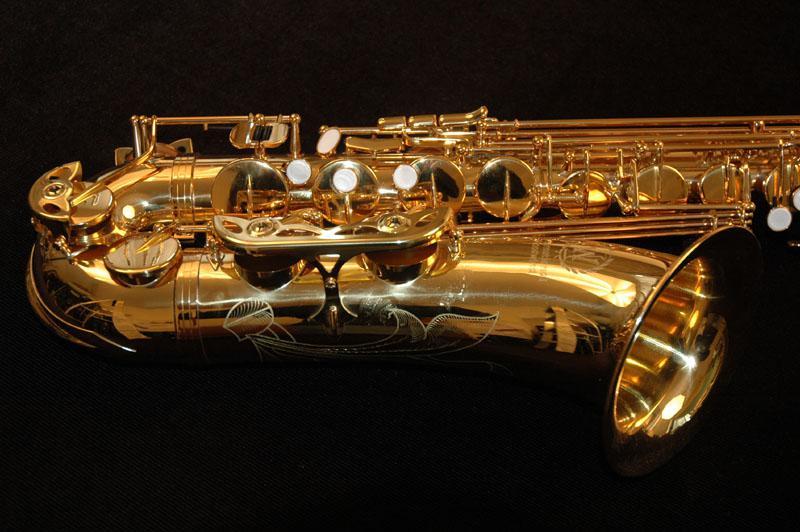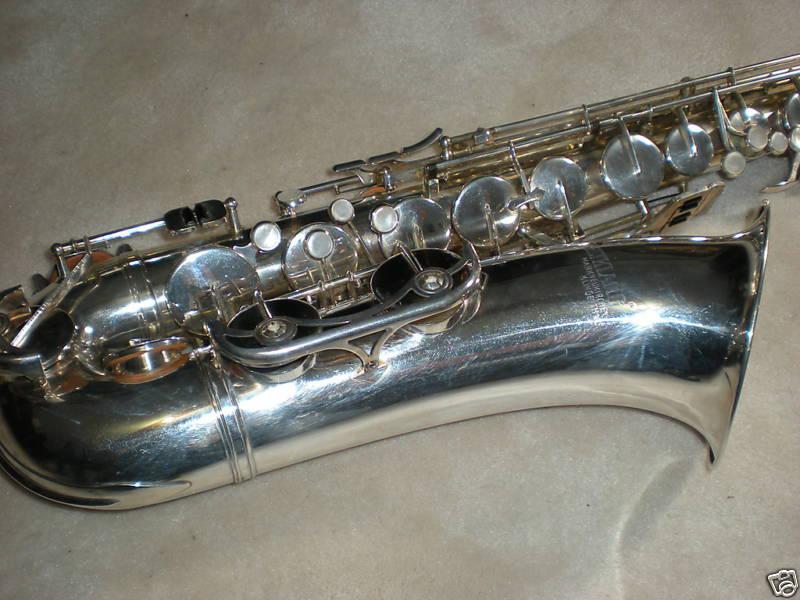The first image is the image on the left, the second image is the image on the right. Assess this claim about the two images: "Both saxophones are positioned with their bells to the right.". Correct or not? Answer yes or no. Yes. The first image is the image on the left, the second image is the image on the right. Examine the images to the left and right. Is the description "The bell ends of two saxophones in different colors are lying horizontally, pointed toward the same direction." accurate? Answer yes or no. Yes. 